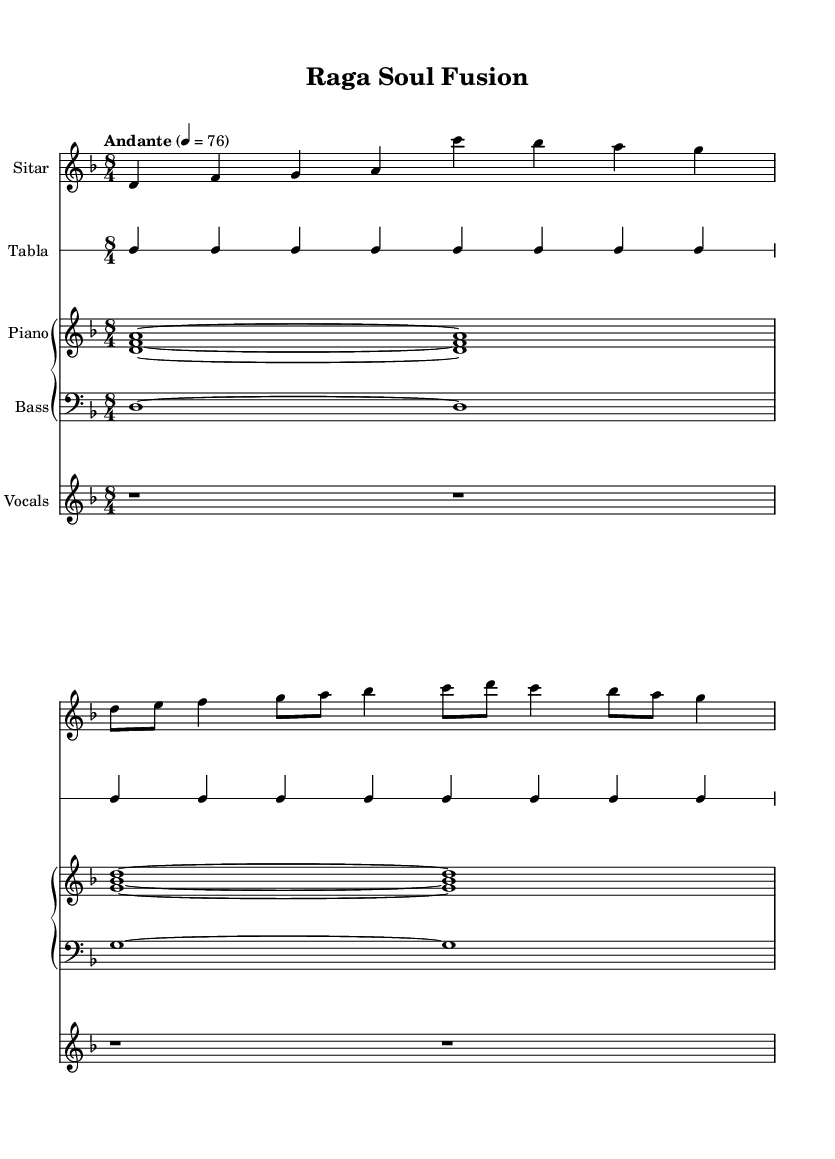What is the key signature of this music? The key signature indicated in the score is D minor, which has one flat (B flat). This is identified by the specific notation at the beginning of the music.
Answer: D minor What is the time signature of this music? The time signature shown at the beginning of the score is 8/4, which means there are eight beats in each measure and a quarter note gets one beat. This is visible right after the key signature at the start of the music.
Answer: 8/4 What is the tempo marking of this piece? The tempo marking indicates "Andante," which suggests a moderate pace of walking speed. This is typically placed at the top of the score, just below the title.
Answer: Andante How many measures does the sitar part have? The sitar part consists of four measures, counted by the number of vertical lines separating the musical segments. Upon analyzing the notations for the sitar, there are four clear divisions that constitute four measures.
Answer: 4 What clef is used for the tabla in this piece? The tabla is written in percussion clef, which is designated by the specific clef symbol at the beginning of its staff. This indicates it is a rhythm instrument rather than a pitch-based one.
Answer: Percussion Which instruments are included in this score? The score features four distinct instruments: sitar, tabla, piano, and bass. This is determined by looking at the different staves labeled at the beginning of each section, where each instrument is specified.
Answer: Sitar, tabla, piano, bass What type of fusion does this music represent? This music represents a fusion of traditional Indian classical music, particularly the use of sitar and tabla, with contemporary soul rhythms, signified by the harmony provided by the piano and bass lines. The blend is emphasized by the rhythmic structure and melodic lines.
Answer: Traditional Indian classical and contemporary soul 